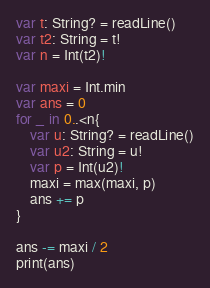Convert code to text. <code><loc_0><loc_0><loc_500><loc_500><_Swift_>var t: String? = readLine()
var t2: String = t!
var n = Int(t2)!

var maxi = Int.min
var ans = 0
for _ in 0..<n{
    var u: String? = readLine()
    var u2: String = u!
    var p = Int(u2)!
    maxi = max(maxi, p)
    ans += p
}

ans -= maxi / 2
print(ans)</code> 